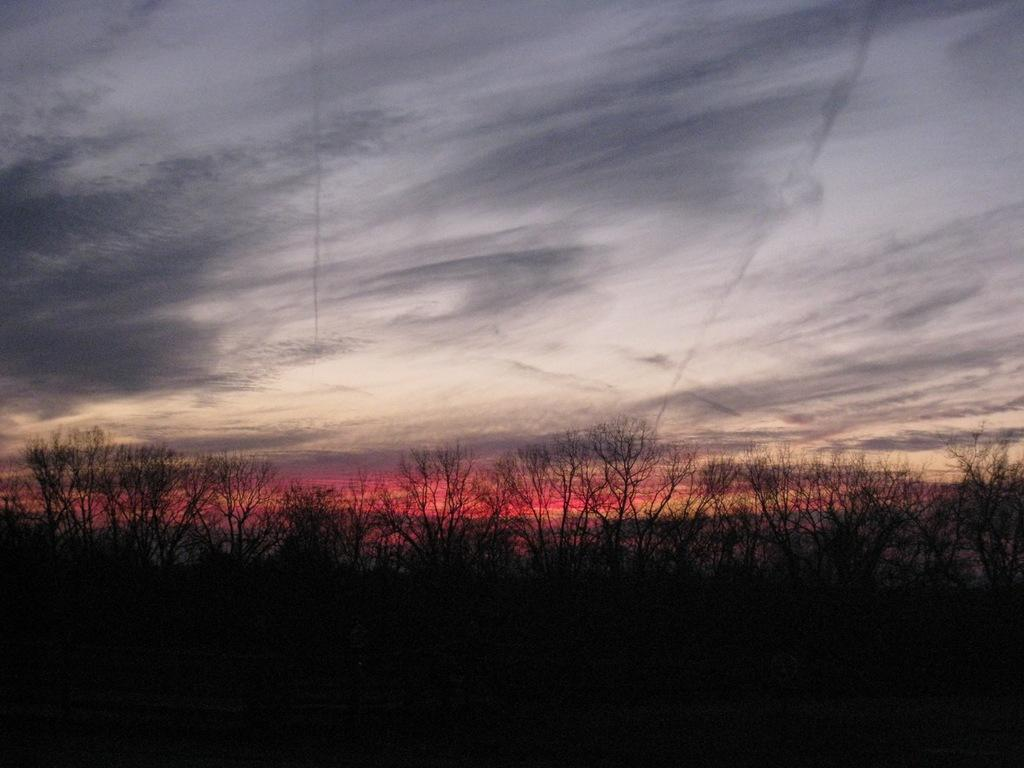What type of vegetation can be seen in the image? There is a group of trees in the image. What is visible at the top of the image? The sky is visible at the top of the image. What is the price of the bat in the image? There is no bat present in the image, so it is not possible to determine its price. 